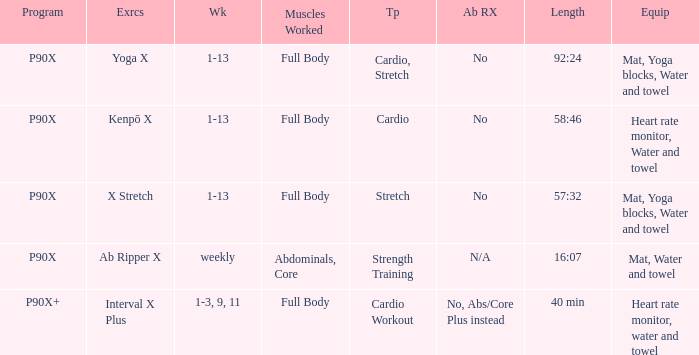What is the ab ripper x when the length is 92:24? No. 